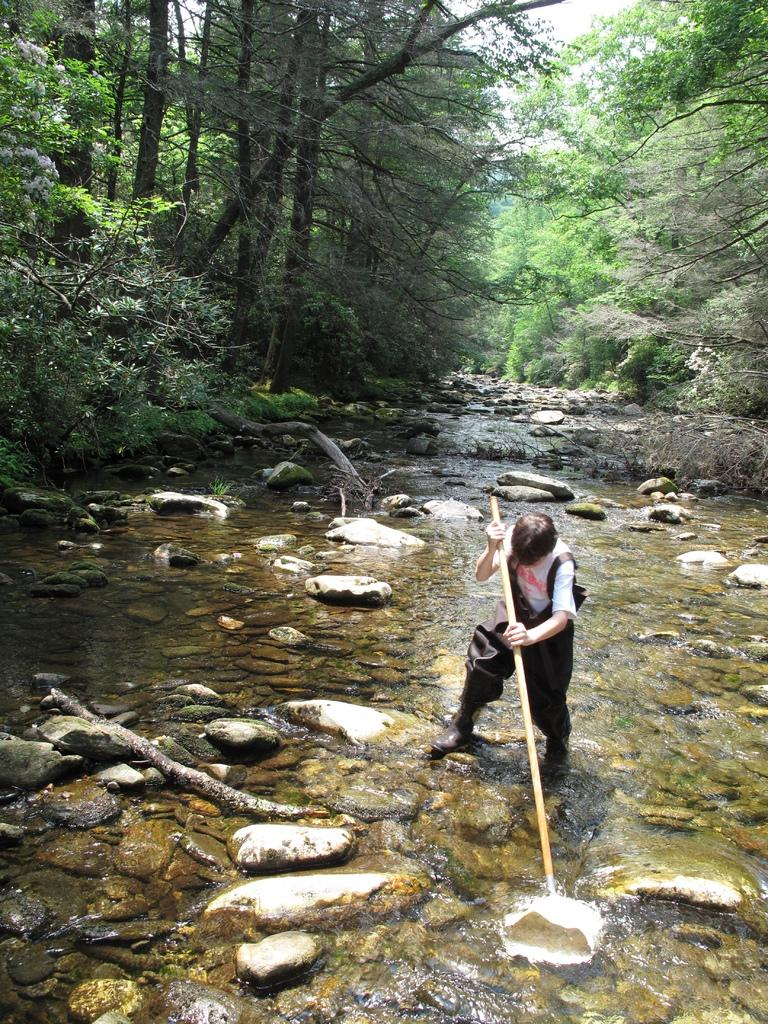What is the person in the image doing? There is a person standing in the water in the image. What object is the person holding in their hands? The person is holding a stick in their hands. What can be seen in the water besides the person? There are stones in the water. What is visible in the background of the image? There are trees in the background of the image. How many pages of the book can be seen in the image? There is no book present in the image, so it's not possible to determine how many pages can be seen. What color are the person's toes in the image? The image does not show the person's toes, so it's not possible to determine their color. 